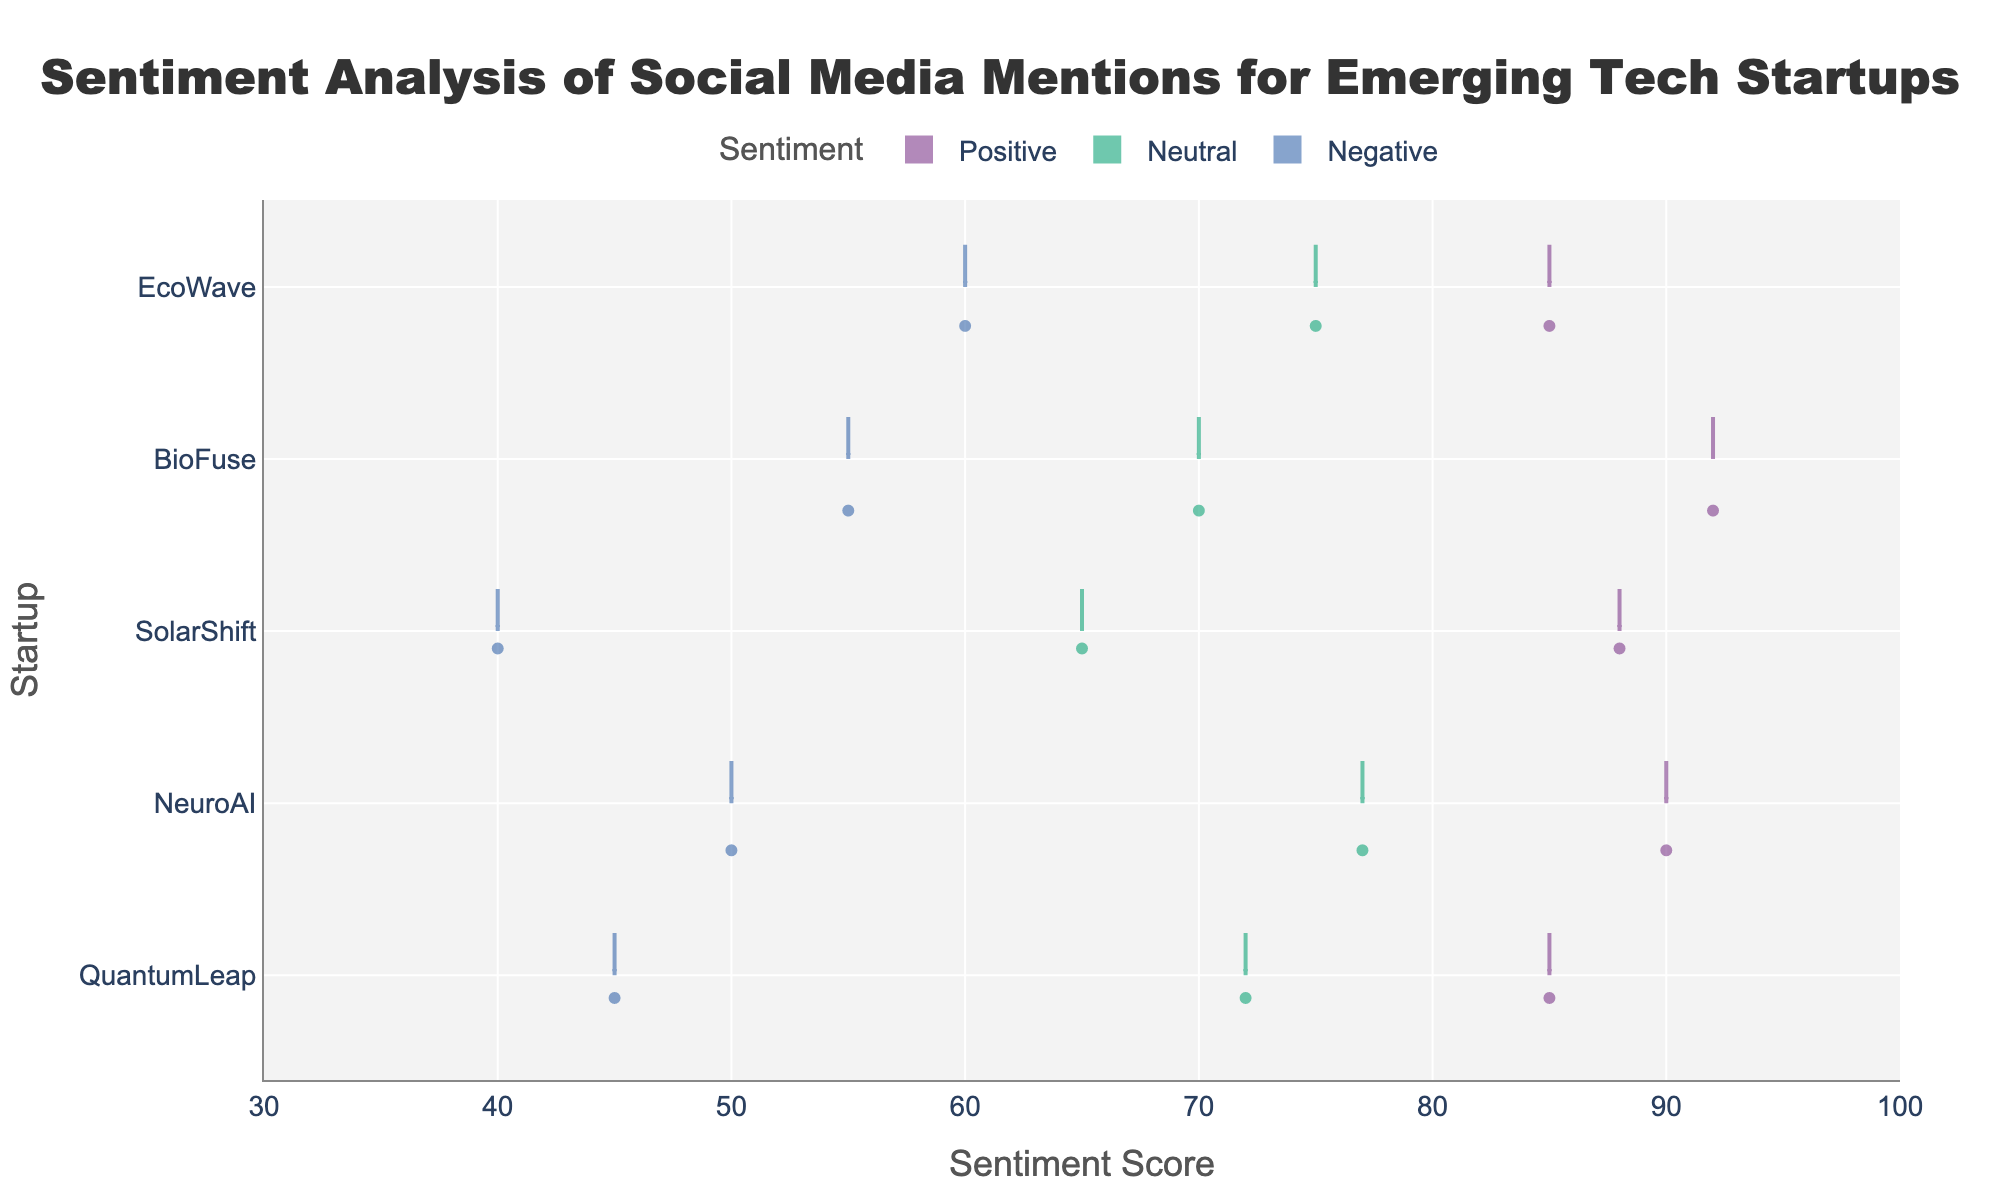what is the title of the figure? The title is generally at the top center of the figure. By reading it directly, you can see it says "Sentiment Analysis of Social Media Mentions for Emerging Tech Startups".
Answer: Sentiment Analysis of Social Media Mentions for Emerging Tech Startups what does the horizontal axis represent? The horizontal axis is typically labeled clearly. In this figure, it is labeled "Sentiment Score".
Answer: Sentiment Score how many startups are included in the analysis? Each startup has its name listed on the vertical axis. By counting the unique names, we see there are five startups: QuantumLeap, NeuroAI, SolarShift, BioFuse, and EcoWave.
Answer: 5 which startup has the highest average positive sentiment score? To find this, look at the central tendency (mean line) within the 'Positive' sentiment violins for each startup. BioFuse shows the highest mean line around the 92 mark.
Answer: BioFuse which sentiment has the most variation in scores across all startups? Variation can be seen by the spread of the violin plot. The 'Positive' sentiment generally shows smaller spreads, so look closely at 'Negative' which has a broad range particularly noticeable toward lower scores. This can be seen as having more variation in its violin shape.
Answer: Negative which startup shows the lowest negative sentiment score? By examining the lower tail of the 'Negative' sentiment violins, SolarShift's violin plot dips the lowest, down to around 40.
Answer: SolarShift how does the neutral sentiment score for QuantumLeap compare to NeuroAI? By looking at the mean lines in the 'Neutral' sentiment violins, QuantumLeap’s mean is around 72, whereas NeuroAI's is slightly higher, around 77. Therefore, NeuroAI's score is higher.
Answer: NeuroAI has a higher neutral sentiment score than QuantumLeap what is the average positive sentiment score for EcoWave? To get the specific mean value, look at the mean line (central white dot) within the 'Positive' violin for EcoWave. The mean line lies around 85.
Answer: 85 which sentiment category has the closest score range across all startups? For the closest score range, check for a similar span among all startups within the same sentiment. 'Positive' sentiment shows a tight clustering of scores between 85 to 92 for all startups, representing the closest range.
Answer: Positive which startup exhibits the most balanced sentiment scores across all categories? A startup with balanced scores will have similar spans and mean lines across 'Positive,' 'Neutral,' and 'Negative.' QuantumLeap, for instance, shows a middle-ground for all sentiments without extreme deviations, indicating balanced sentiment.
Answer: QuantumLeap 